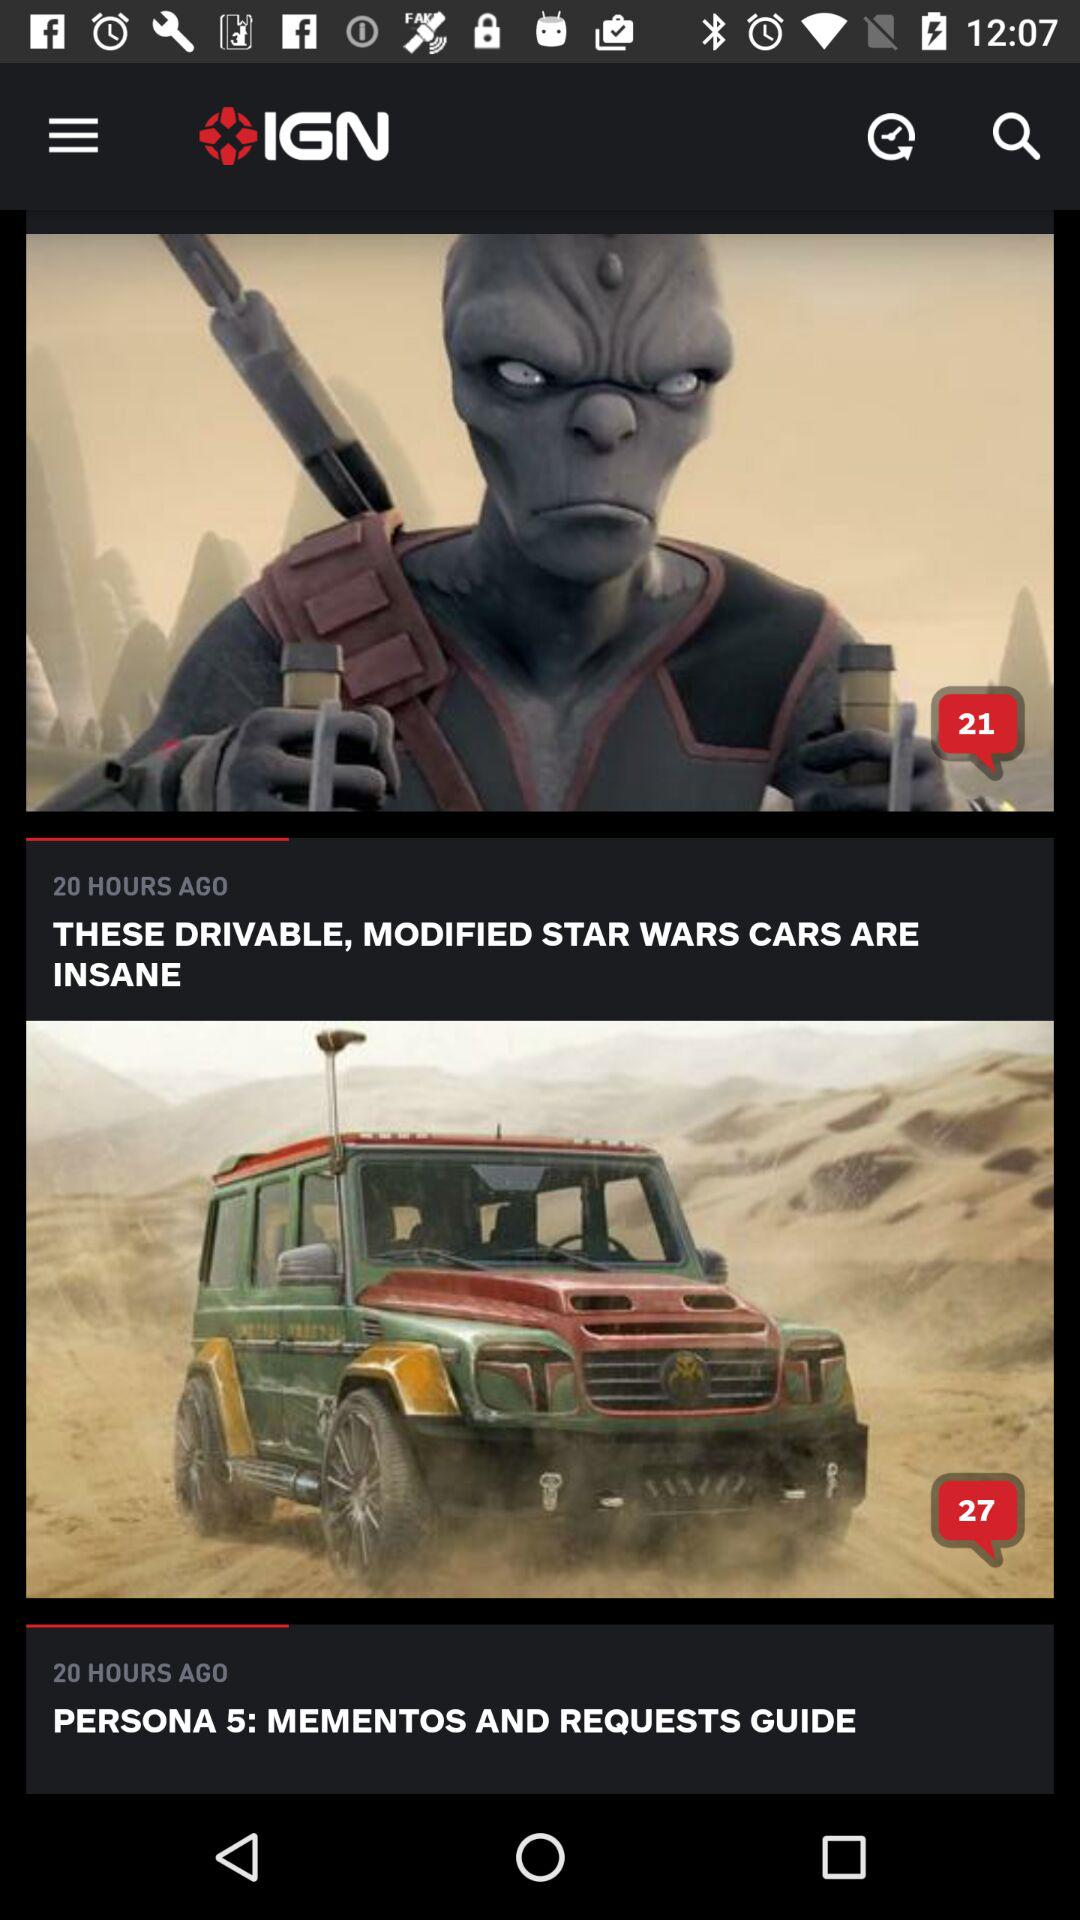How many comments on "PERSONA 5: MEMENTOS AND REQUESTS GUIDE"? There are 27 comments. 